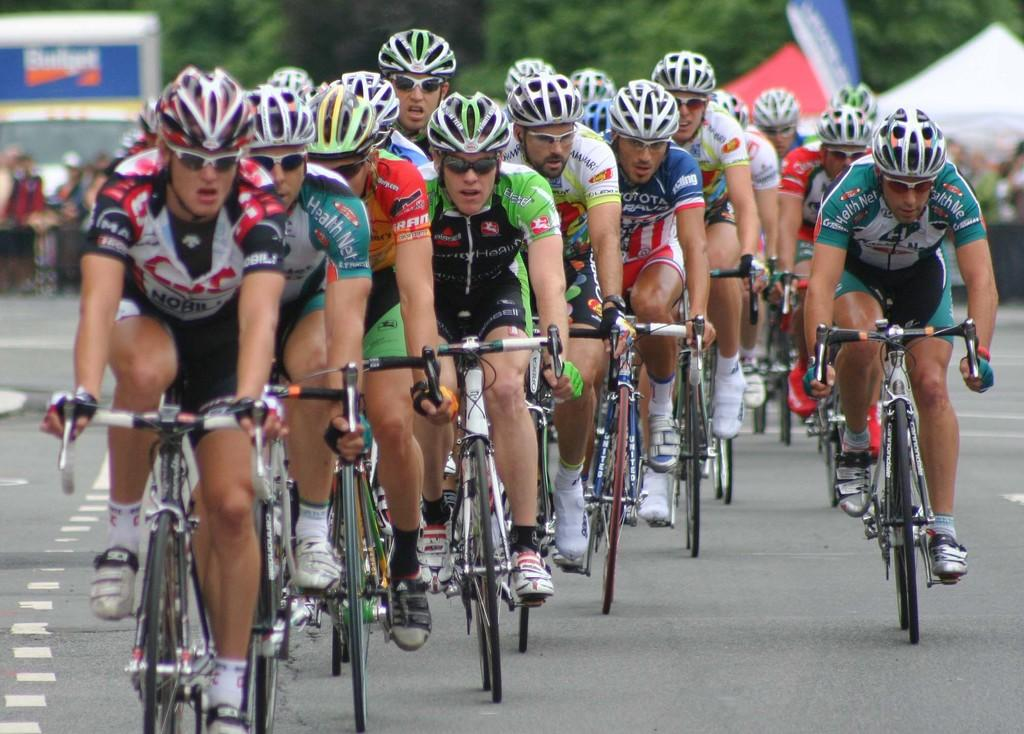What are the people in the image doing? The people in the image are riding bicycles. What type of event might be taking place in the image? It appears to be a cycle race. What can be seen in the background of the image? There are green trees in the background of the image. What is the texture of the rabbits' fur in the image? There are no rabbits present in the image, so we cannot determine the texture of their fur. 